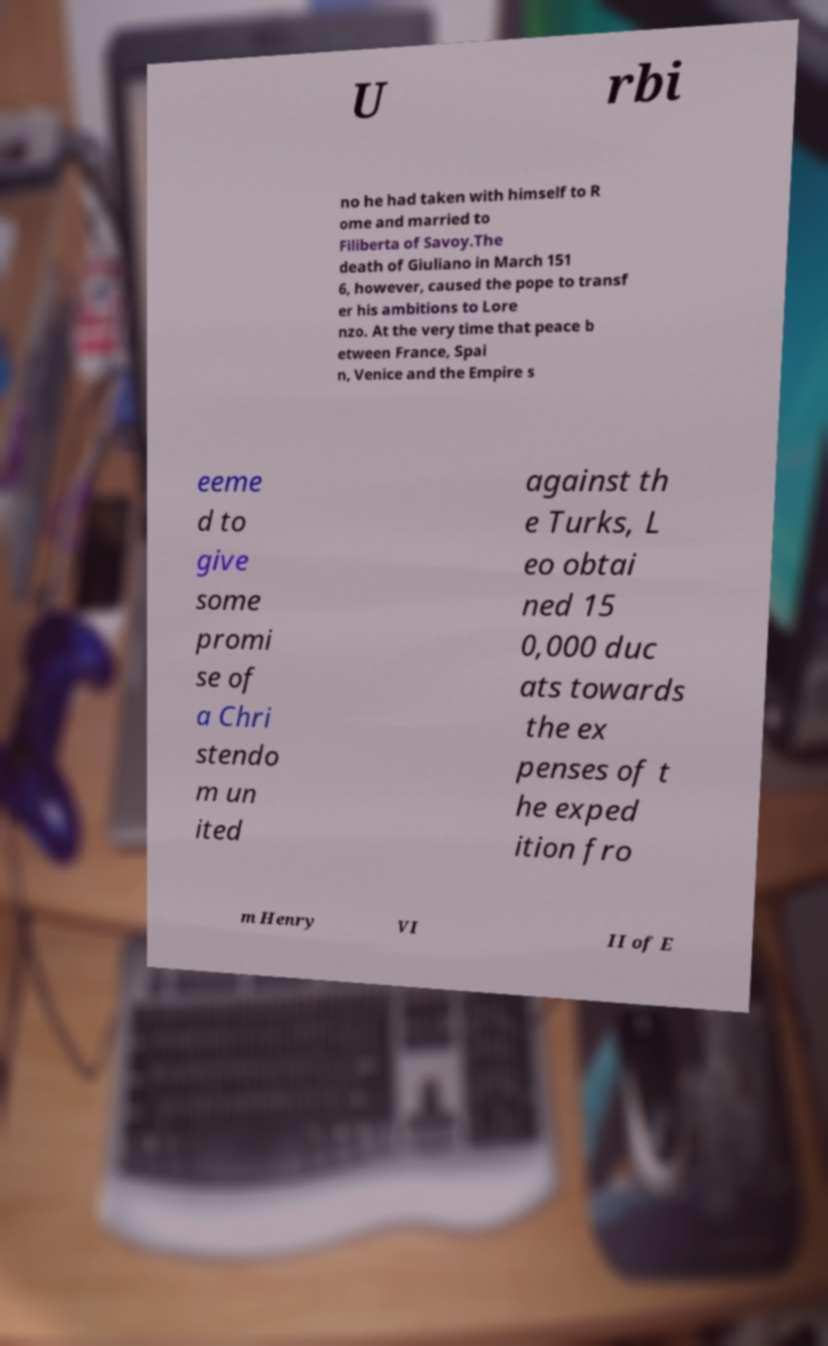Could you extract and type out the text from this image? U rbi no he had taken with himself to R ome and married to Filiberta of Savoy.The death of Giuliano in March 151 6, however, caused the pope to transf er his ambitions to Lore nzo. At the very time that peace b etween France, Spai n, Venice and the Empire s eeme d to give some promi se of a Chri stendo m un ited against th e Turks, L eo obtai ned 15 0,000 duc ats towards the ex penses of t he exped ition fro m Henry VI II of E 